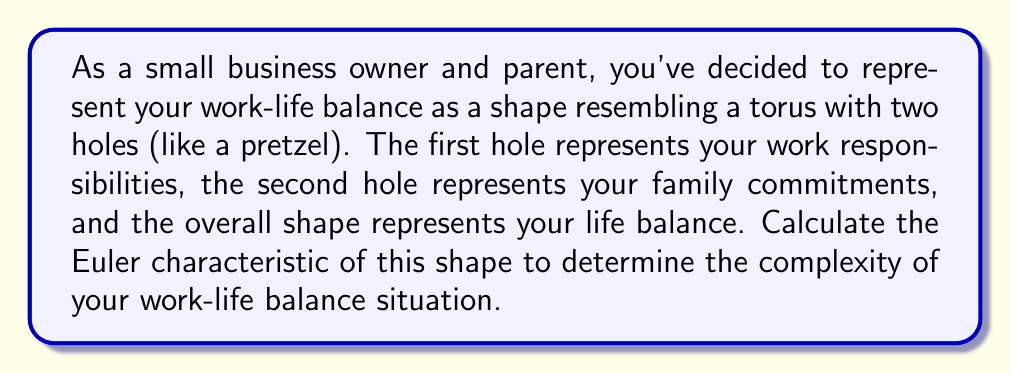Can you answer this question? To calculate the Euler characteristic of a shape, we use the formula:

$$\chi = V - E + F$$

Where:
$\chi$ (chi) is the Euler characteristic
$V$ is the number of vertices
$E$ is the number of edges
$F$ is the number of faces

For a torus with two holes (also known as a 2-torus or genus 2 surface):

1. Vertices (V): A torus with two holes can be represented with a single vertex. So, $V = 1$.

2. Edges (E): We need 4 edges to create the two holes. So, $E = 4$.

3. Faces (F): The surface consists of a single face. So, $F = 1$.

Now, let's plug these values into the Euler characteristic formula:

$$\chi = V - E + F$$
$$\chi = 1 - 4 + 1$$
$$\chi = -2$$

The Euler characteristic of a genus g surface (a sphere with g handles) is given by the formula:

$$\chi = 2 - 2g$$

Where g is the genus (number of holes). In this case, g = 2, which confirms our calculation:

$$\chi = 2 - 2(2) = -2$$

This negative Euler characteristic indicates a complex topological structure, reflecting the challenges of balancing work and family responsibilities.
Answer: $$\chi = -2$$ 